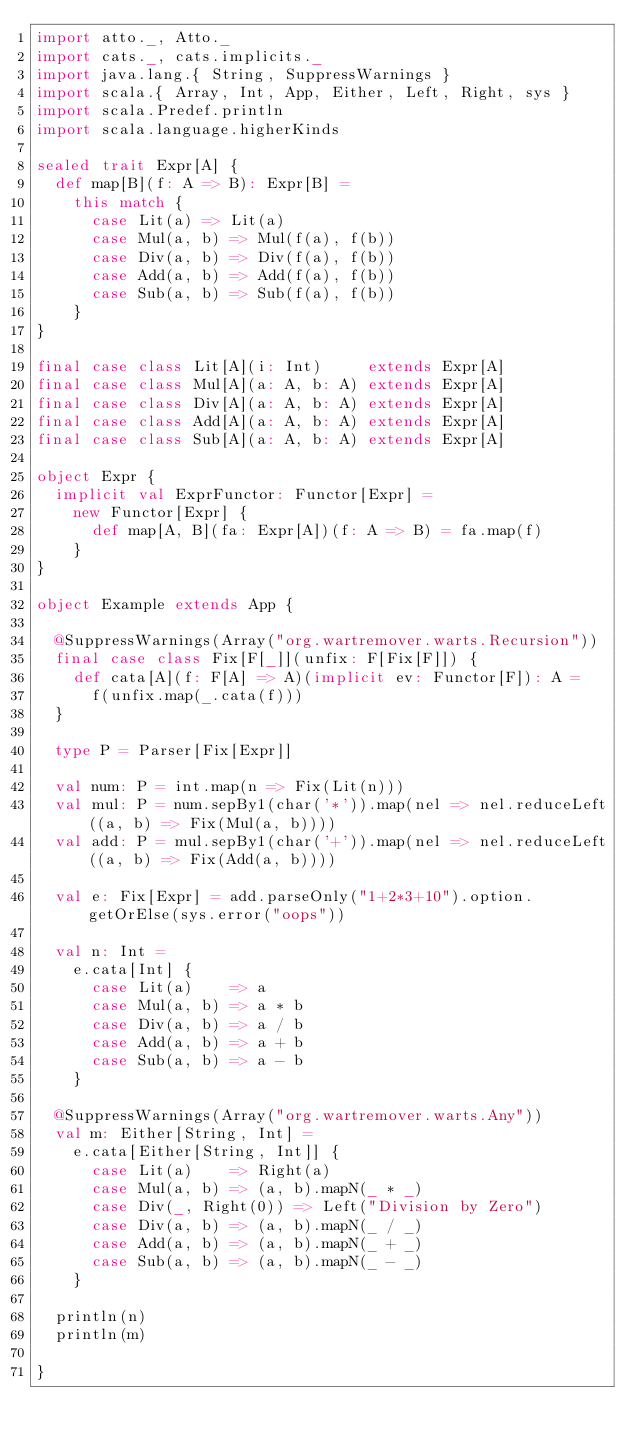<code> <loc_0><loc_0><loc_500><loc_500><_Scala_>import atto._, Atto._
import cats._, cats.implicits._
import java.lang.{ String, SuppressWarnings }
import scala.{ Array, Int, App, Either, Left, Right, sys }
import scala.Predef.println
import scala.language.higherKinds

sealed trait Expr[A] {
  def map[B](f: A => B): Expr[B] =
    this match {
      case Lit(a) => Lit(a)
      case Mul(a, b) => Mul(f(a), f(b))
      case Div(a, b) => Div(f(a), f(b))
      case Add(a, b) => Add(f(a), f(b))
      case Sub(a, b) => Sub(f(a), f(b))
    }
}

final case class Lit[A](i: Int)     extends Expr[A]
final case class Mul[A](a: A, b: A) extends Expr[A]
final case class Div[A](a: A, b: A) extends Expr[A]
final case class Add[A](a: A, b: A) extends Expr[A]
final case class Sub[A](a: A, b: A) extends Expr[A]

object Expr {
  implicit val ExprFunctor: Functor[Expr] =
    new Functor[Expr] {
      def map[A, B](fa: Expr[A])(f: A => B) = fa.map(f)
    }
}

object Example extends App {

  @SuppressWarnings(Array("org.wartremover.warts.Recursion"))
  final case class Fix[F[_]](unfix: F[Fix[F]]) {
    def cata[A](f: F[A] => A)(implicit ev: Functor[F]): A =
      f(unfix.map(_.cata(f)))
  }

  type P = Parser[Fix[Expr]]

  val num: P = int.map(n => Fix(Lit(n)))
  val mul: P = num.sepBy1(char('*')).map(nel => nel.reduceLeft((a, b) => Fix(Mul(a, b))))
  val add: P = mul.sepBy1(char('+')).map(nel => nel.reduceLeft((a, b) => Fix(Add(a, b))))

  val e: Fix[Expr] = add.parseOnly("1+2*3+10").option.getOrElse(sys.error("oops"))

  val n: Int =
    e.cata[Int] {
      case Lit(a)    => a
      case Mul(a, b) => a * b
      case Div(a, b) => a / b
      case Add(a, b) => a + b
      case Sub(a, b) => a - b
    }

  @SuppressWarnings(Array("org.wartremover.warts.Any"))
  val m: Either[String, Int] =
    e.cata[Either[String, Int]] {
      case Lit(a)    => Right(a)
      case Mul(a, b) => (a, b).mapN(_ * _)
      case Div(_, Right(0)) => Left("Division by Zero")
      case Div(a, b) => (a, b).mapN(_ / _)
      case Add(a, b) => (a, b).mapN(_ + _)
      case Sub(a, b) => (a, b).mapN(_ - _)
    }

  println(n)
  println(m)

}
</code> 